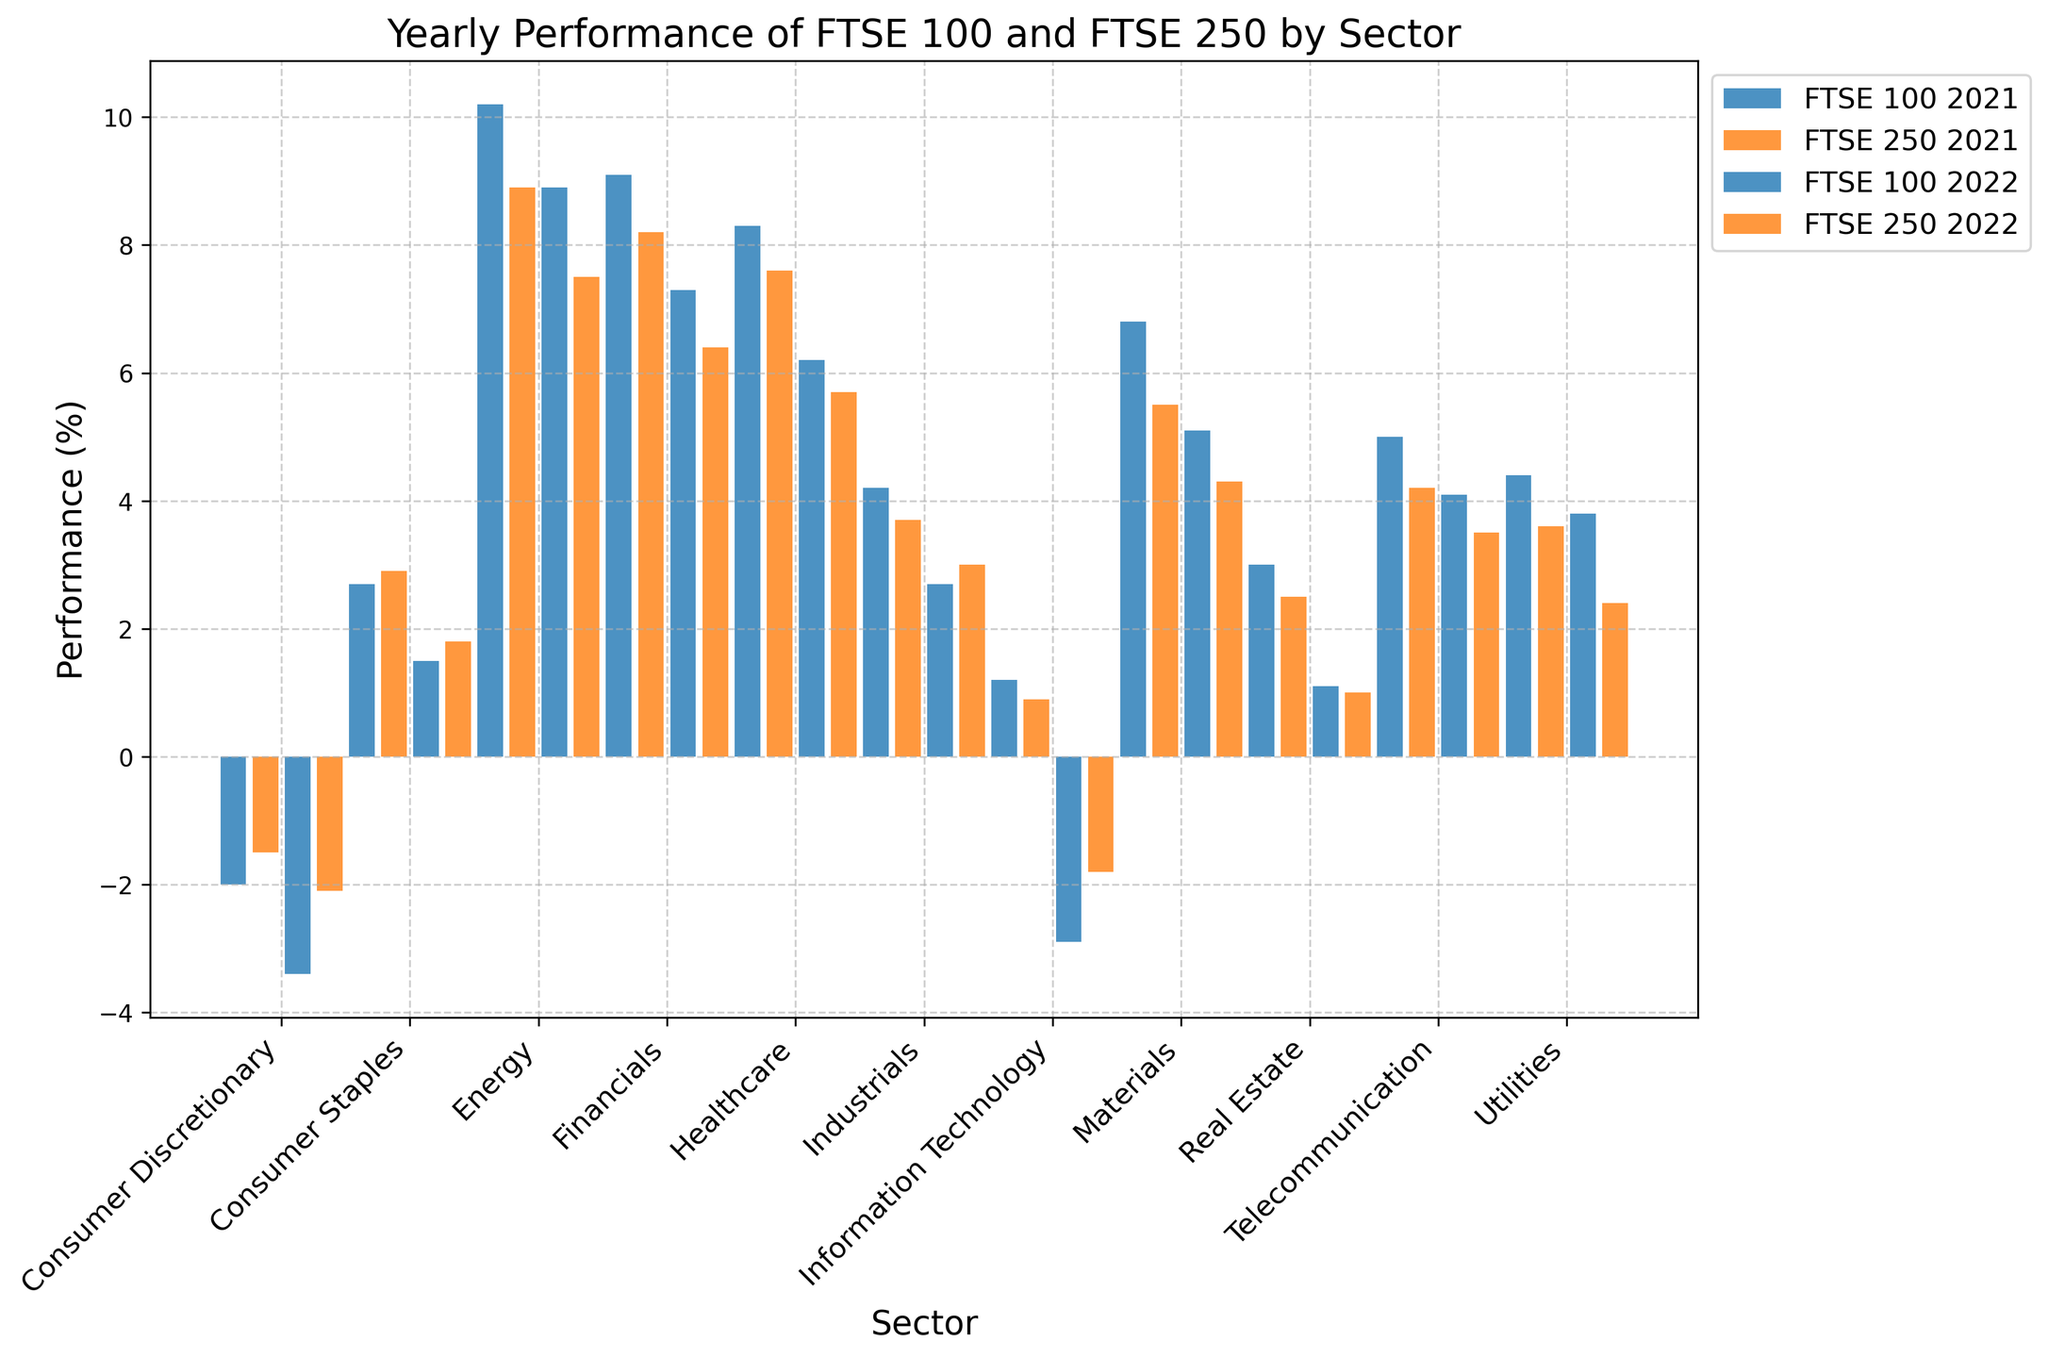Which sector had the highest performance in FTSE 100 in 2022? The bars representing FTSE 100 for 2022 can be compared for height. The Energy sector has the tallest bar, indicating the highest performance.
Answer: Energy What is the difference in performance between FTSE 100 and FTSE 250 in the Financials sector for 2022? In 2022, the Financials sector performance is 7.3 for FTSE 100 and 6.4 for FTSE 250. The difference is calculated as 7.3 - 6.4.
Answer: 0.9 Which has more consistent performance improvement across the sectors, FTSE 100 or FTSE 250, from 2021 to 2022? Consistency can be observed by noting how performance changes across sectors from 2021 to 2022. FTSE 100 shows larger variations (e.g., Consumer Discretionary drops more, Information Technology drops less), whereas FTSE 250 shows smaller variations in performance changes, indicating more consistency.
Answer: FTSE 250 Which index had better performance in the Telecommunications sector in 2022, and by how much? For 2022, compare the bars for FTSE 100 and FTSE 250 in the Telecommunications sector. FTSE 100 is at 4.1 and FTSE 250 is at 3.5. The difference is 4.1 - 3.5.
Answer: FTSE 100, by 0.6 In which sector did FTSE 250 see negative performance in 2022? Identify bars below the zero line for FTSE 250 in 2022. The Consumer Discretionary sector has a bar below zero in 2022, indicating a negative performance of -2.1%.
Answer: Consumer Discretionary What was the combined performance of FTSE 100 and FTSE 250 in the Energy sector for 2022? Calculate the sum of the performance values for FTSE 100 and FTSE 250 in the Energy sector for 2022. FTSE 100 is 8.9 and FTSE 250 is 7.5. The combined performance is 8.9 + 7.5.
Answer: 16.4 Which sector showed a decrease in performance for both FTSE 100 and FTSE 250 from 2021 to 2022? Compare the heights of the bars in 2021 and 2022 for each index in each sector. The Consumer Discretionary sector shows a decrease in both FTSE 100 (-2.0 to -3.4) and FTSE 250 (-1.5 to -2.1).
Answer: Consumer Discretionary What is the average performance of FTSE 100 across all sectors in 2022? Sum the performances of FTSE 100 across all sectors for 2022 and divide by the number of sectors (11). The sum is 8.9 + 5.1 + 2.7 - 3.4 + 1.5 + 6.2 + 7.3 - 2.9 + 4.1 + 3.8 + 1.1 = 34.4. The average is 34.4 / 11.
Answer: 3.13 Which sector had the largest drop in performance for FTSE 100 from 2021 to 2022? Identify the performance changes for each sector by subtracting 2022 values from 2021 values for FTSE 100. The largest decrease comes from the Consumer Discretionary sector, changing from -2.0 in 2021 to -3.4 in 2022, a drop of -1.4.
Answer: Consumer Discretionary 